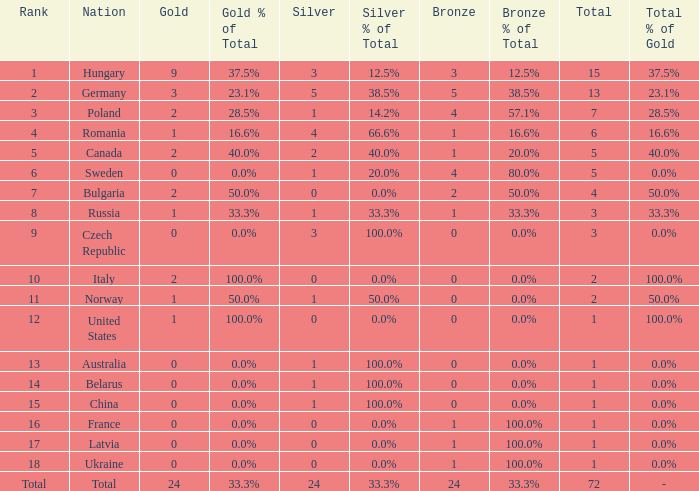What average silver has belarus as the nation, with a total less than 1? None. 